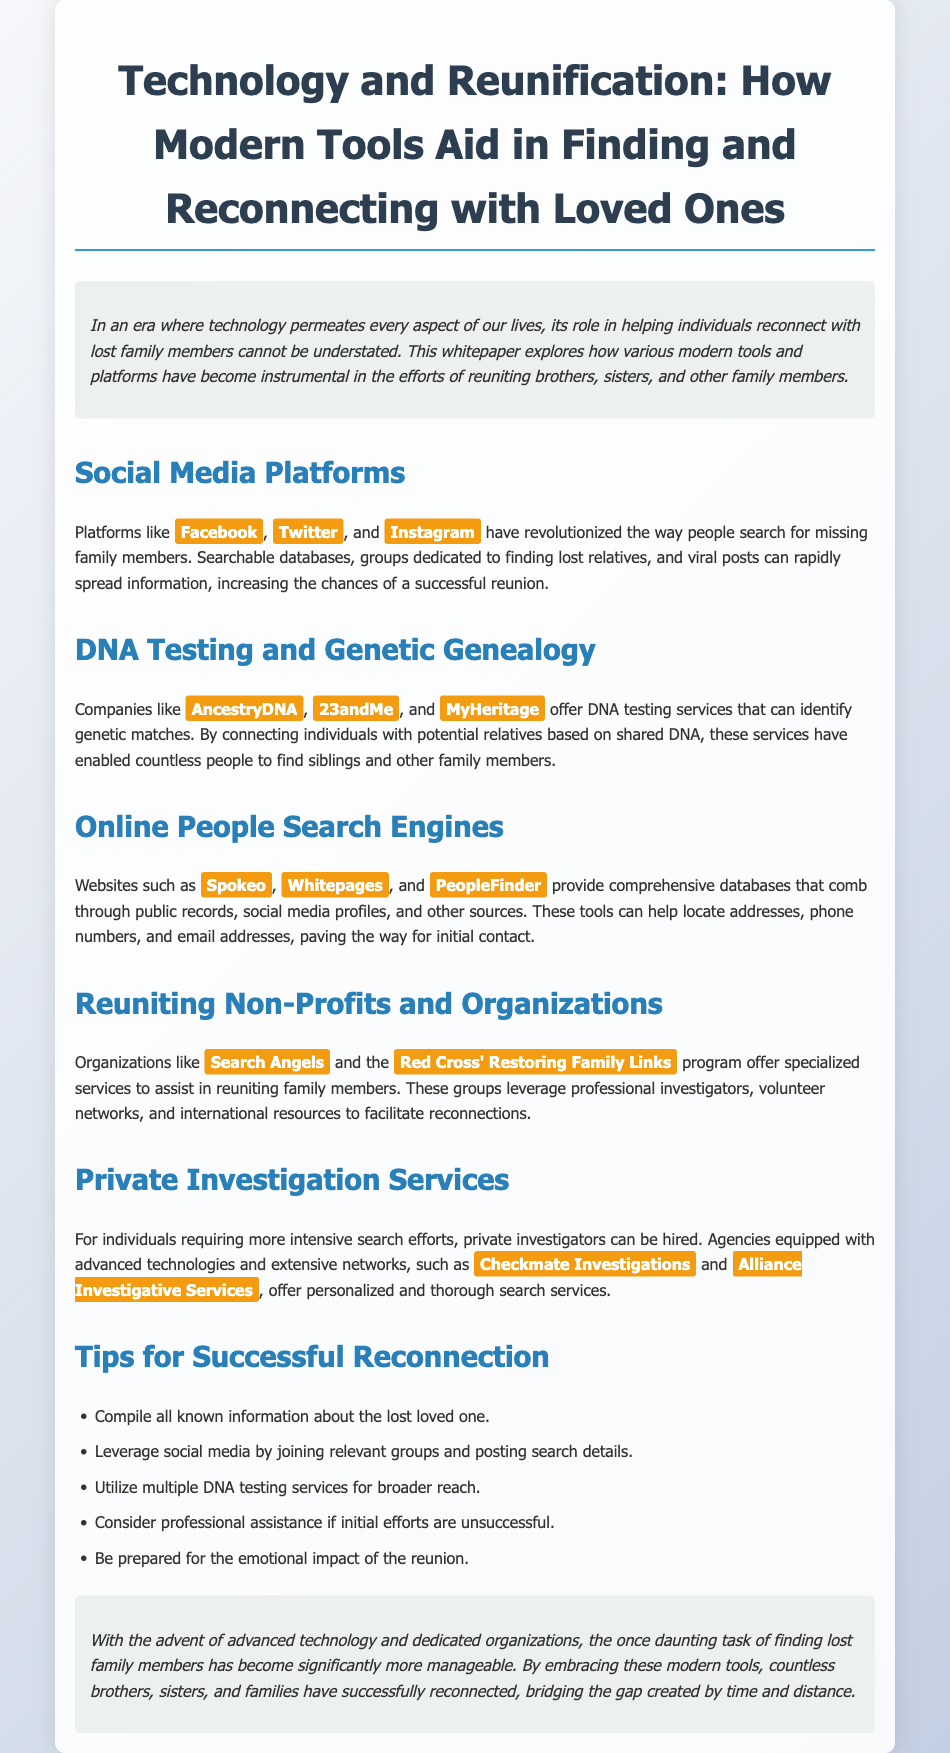What role do social media platforms play in locating lost family members? Social media platforms revolutionize the way people search for missing family members by increasing the chances of a successful reunion through viral posts and dedicated groups.
Answer: They increase chances of reunion Which DNA testing companies help identify genetic matches? Companies mentioned for identifying genetic matches include AncestryDNA, 23andMe, and MyHeritage.
Answer: AncestryDNA, 23andMe, MyHeritage What do online people search engines provide? Online people search engines like Spokeo, Whitepages, and PeopleFinder provide comprehensive databases that pull from public records, social media profiles, and more.
Answer: Comprehensive databases Name a non-profit organization that aids in reuniting family members. One of the non-profit organizations mentioned is Search Angels.
Answer: Search Angels How many tips for successful reconnection are listed in the document? The document lists five tips for successful reconnection.
Answer: Five What is a suggested action when initial efforts to reconnect are unsuccessful? The document suggests considering professional assistance if initial efforts are unsuccessful.
Answer: Consider professional assistance What emotional aspect should one be prepared for regarding reunions? The document advises to be prepared for the emotional impact of the reunion.
Answer: Emotional impact What type of services can private investigators offer? Private investigators can offer personalized and thorough search services for individuals needing intensive searches.
Answer: Personalized and thorough search services What is the purpose of this whitepaper? The whitepaper explores how modern tools and platforms aid in reuniting family members.
Answer: Aid in reuniting family members 